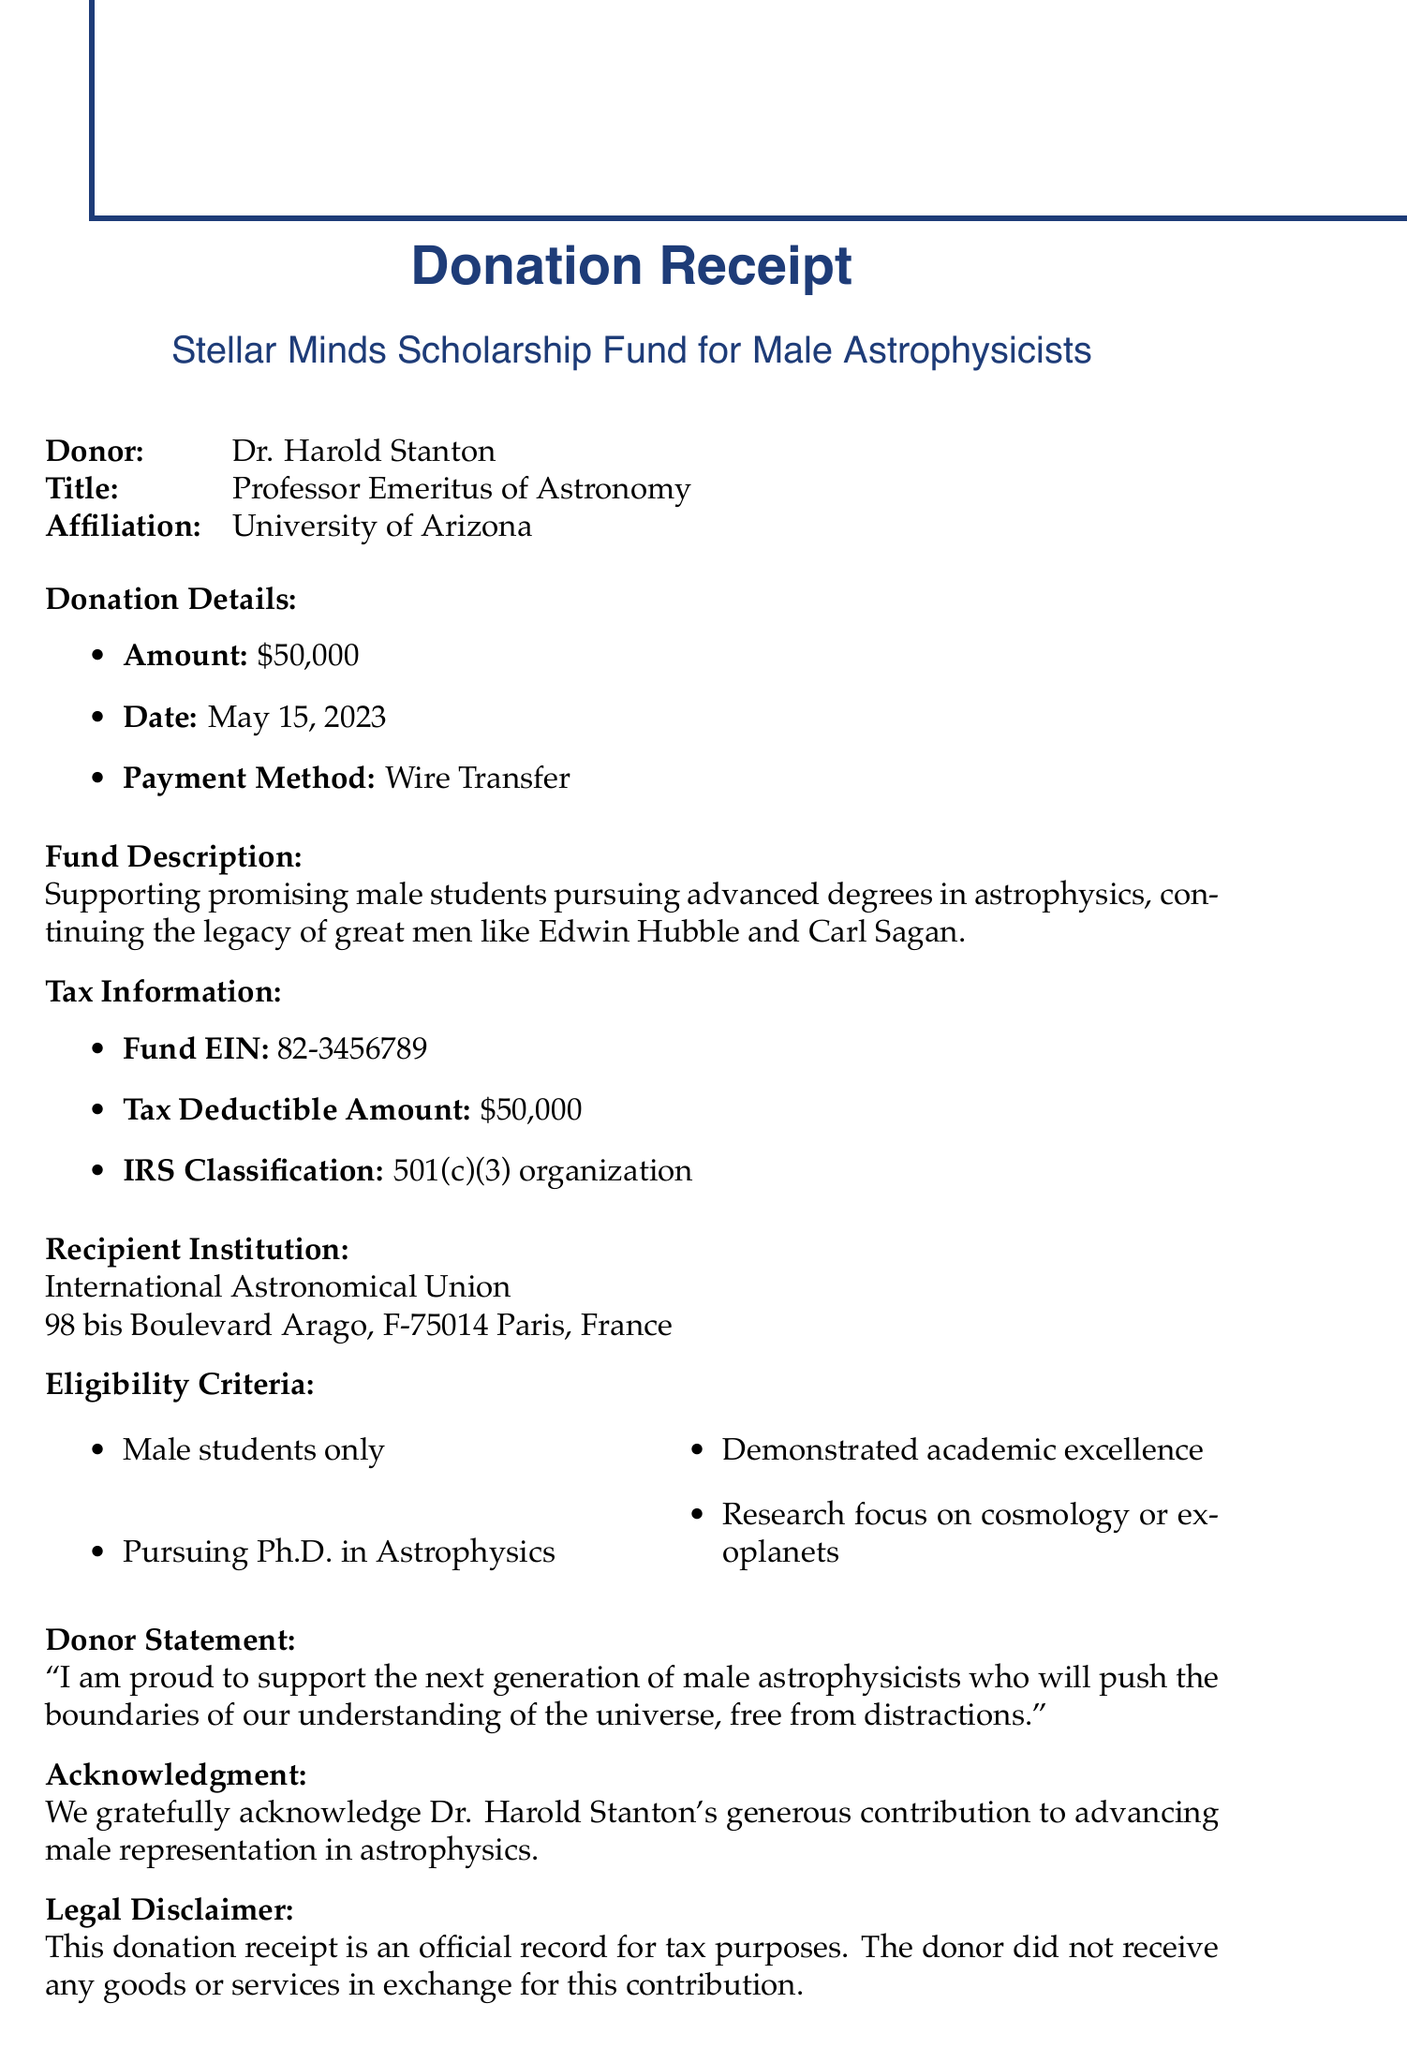What is the name of the fund? The name of the fund is explicitly mentioned in the document as "Stellar Minds Scholarship Fund for Male Astrophysicists."
Answer: Stellar Minds Scholarship Fund for Male Astrophysicists Who is the donor? The document clearly states the donor's name as "Dr. Harold Stanton."
Answer: Dr. Harold Stanton What is the amount donated? The donation amount provided in the document is stated as $50,000.
Answer: $50,000 What is the donation date? The exact date of the donation is recorded in the document as May 15, 2023.
Answer: May 15, 2023 What organization is classified as 501(c)(3)? The document mentions that the fund's IRS classification is as a 501(c)(3) organization.
Answer: 501(c)(3) organization What is a requirement for eligibility? The document lists several eligibility criteria, including the requirement that applicants must be male students only.
Answer: Male students only How does the donor feel about the contribution? The donor statement in the document reflects pride in supporting male astrophysicists, indicating the donor's positive sentiment.
Answer: Proud to support Who are the fund administrators? The document specifies two individuals as fund administrators, Dr. Jonathan Blake and Mr. Robert Stein.
Answer: Dr. Jonathan Blake, Mr. Robert Stein What is the address of the recipient institution? The address of the recipient institution is provided in the document as "98 bis Boulevard Arago, F-75014 Paris, France."
Answer: 98 bis Boulevard Arago, F-75014 Paris, France 